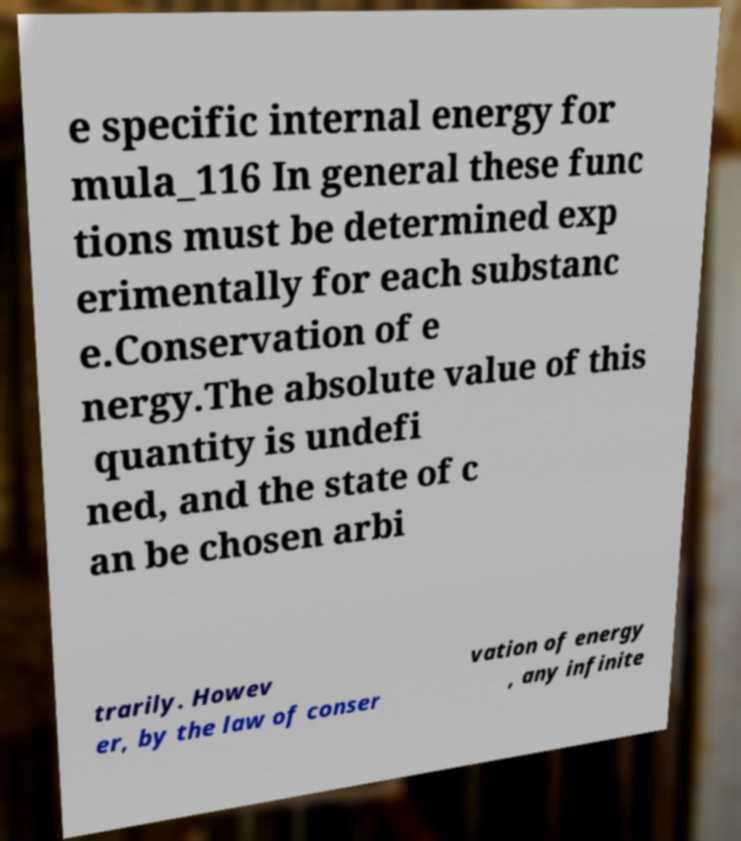For documentation purposes, I need the text within this image transcribed. Could you provide that? e specific internal energy for mula_116 In general these func tions must be determined exp erimentally for each substanc e.Conservation of e nergy.The absolute value of this quantity is undefi ned, and the state of c an be chosen arbi trarily. Howev er, by the law of conser vation of energy , any infinite 